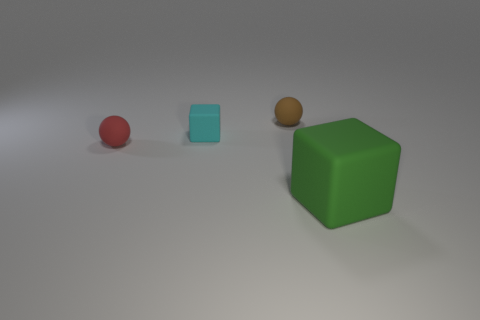How many cylinders have the same size as the red object?
Provide a short and direct response. 0. There is a thing to the right of the small matte thing on the right side of the small matte block; what shape is it?
Your response must be concise. Cube. Are there fewer tiny brown matte balls than big blue things?
Provide a succinct answer. No. There is a small matte ball behind the red ball; what is its color?
Provide a succinct answer. Brown. What is the thing that is both in front of the small cyan block and on the right side of the red rubber sphere made of?
Offer a terse response. Rubber. The green thing that is made of the same material as the small cyan cube is what shape?
Give a very brief answer. Cube. What number of objects are to the left of the brown object behind the red sphere?
Make the answer very short. 2. What number of rubber things are right of the red object and behind the big rubber object?
Provide a short and direct response. 2. The rubber cube that is on the left side of the big matte thing in front of the small red thing is what color?
Your answer should be compact. Cyan. Does the green rubber thing have the same size as the red rubber ball?
Keep it short and to the point. No. 